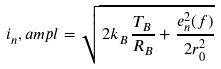Convert formula to latex. <formula><loc_0><loc_0><loc_500><loc_500>i _ { n } , a m p l = \sqrt { \, 2 k _ { B } \frac { T _ { B } } { R _ { B } } + \frac { e _ { n } ^ { 2 } ( f ) } { 2 r _ { 0 } ^ { 2 } } }</formula> 